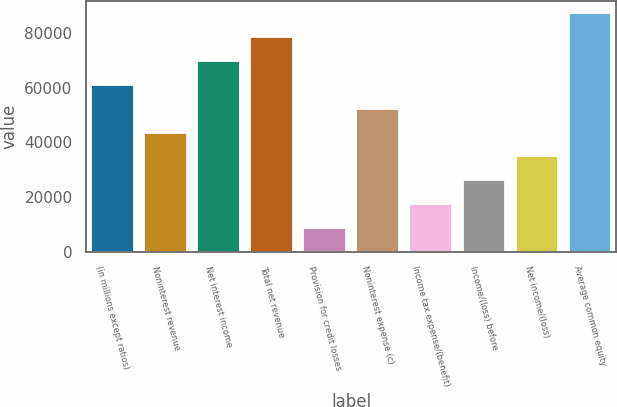Convert chart to OTSL. <chart><loc_0><loc_0><loc_500><loc_500><bar_chart><fcel>(in millions except ratios)<fcel>Noninterest revenue<fcel>Net interest income<fcel>Total net revenue<fcel>Provision for credit losses<fcel>Noninterest expense (c)<fcel>Income tax expense/(benefit)<fcel>Income/(loss) before<fcel>Net income/(loss)<fcel>Average common equity<nl><fcel>61012.4<fcel>43594<fcel>69721.6<fcel>78430.8<fcel>8757.2<fcel>52303.2<fcel>17466.4<fcel>26175.6<fcel>34884.8<fcel>87140<nl></chart> 